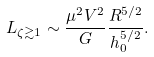Convert formula to latex. <formula><loc_0><loc_0><loc_500><loc_500>L _ { \zeta \gtrsim 1 } \sim \frac { \mu ^ { 2 } V ^ { 2 } } { G } \frac { R ^ { 5 / 2 } } { h _ { 0 } ^ { 5 / 2 } } .</formula> 